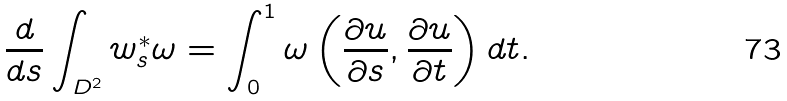<formula> <loc_0><loc_0><loc_500><loc_500>\frac { d } { d s } \int _ { D ^ { 2 } } w _ { s } ^ { * } \omega = \int _ { 0 } ^ { 1 } \omega \left ( \frac { \partial u } { \partial s } , \frac { \partial u } { \partial t } \right ) d t .</formula> 